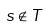Convert formula to latex. <formula><loc_0><loc_0><loc_500><loc_500>s \notin T</formula> 